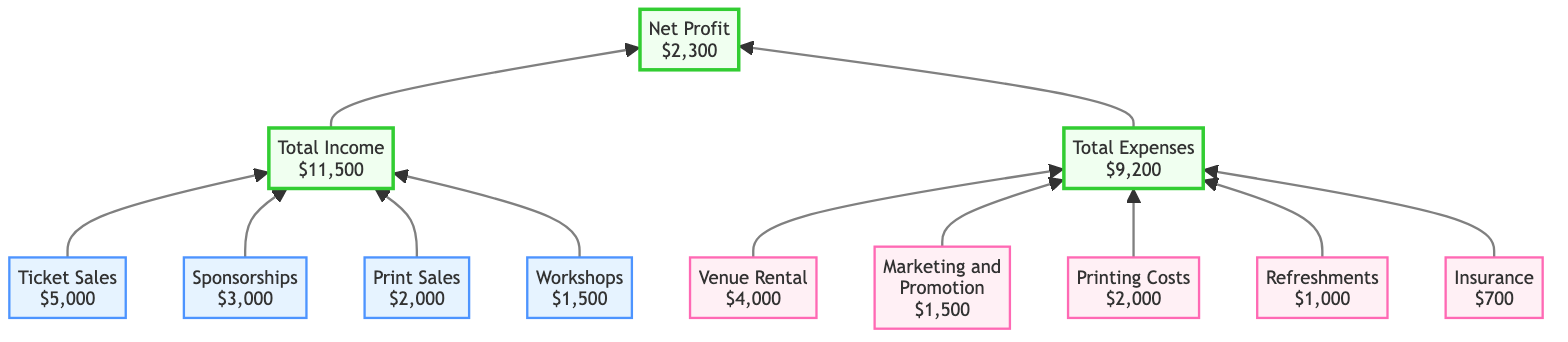What is the total income expected from the exhibit? The diagram shows that the total income has been calculated as the sum of the income streams: Ticket Sales ($5,000) + Sponsorships ($3,000) + Print Sales ($2,000) + Workshops ($1,500). Adding these amounts together yields a total income of $11,500.
Answer: $11,500 What is the estimated amount for marketing and promotion expenses? Looking at the expense section of the diagram, the node for Marketing and Promotion indicates an estimated amount of $1,500.
Answer: $1,500 How much more is the total income than the total expenses? To find out how much more the total income is than total expenses, we need to subtract the total expenses ($9,200) from the total income ($11,500): $11,500 - $9,200 = $2,300. Thus, the difference is $2,300.
Answer: $2,300 Which income stream contributes the least to the total income? The income stream amounts listed are: Ticket Sales ($5,000), Sponsorships ($3,000), Print Sales ($2,000), and Workshops ($1,500). Among these, Workshops has the lowest amount of $1,500, making it the least contributor.
Answer: Workshops What are the total expenses for the exhibit? The total expenses are summarized in the diagram as the sum of all the individual expenses: Venue Rental ($4,000) + Marketing and Promotion ($1,500) + Printing Costs ($2,000) + Refreshments ($1,000) + Insurance ($700), which adds up to $9,200.
Answer: $9,200 How many total expenses are listed in the diagram? The expense section lists five distinct categories of expenses: Venue Rental, Marketing and Promotion, Printing Costs, Refreshments, and Insurance. Therefore, the total number of expense categories is five.
Answer: 5 What does the net profit calculation represent in this diagram? The net profit is calculated by subtracting total expenses ($9,200) from total income ($11,500). This represents the amount left over after all expenses are paid, indicating the overall financial success of the exhibit. The net profit is $2,300.
Answer: $2,300 Which category has the highest estimated amount in the expense section? Reviewing the expenses, the highest estimated amount is found under Venue Rental, which costs $4,000, the largest single expense.
Answer: Venue Rental How are the income streams connected to the total income? The income streams (Ticket Sales, Sponsorships, Print Sales, Workshops) flow into the Total Income node, indicating that the values of these income streams collectively contribute to the overall total income calculation of $11,500.
Answer: Total Income 